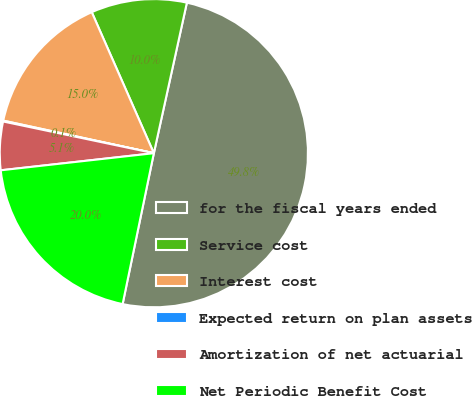Convert chart to OTSL. <chart><loc_0><loc_0><loc_500><loc_500><pie_chart><fcel>for the fiscal years ended<fcel>Service cost<fcel>Interest cost<fcel>Expected return on plan assets<fcel>Amortization of net actuarial<fcel>Net Periodic Benefit Cost<nl><fcel>49.81%<fcel>10.04%<fcel>15.01%<fcel>0.09%<fcel>5.07%<fcel>19.98%<nl></chart> 